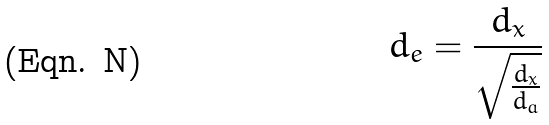Convert formula to latex. <formula><loc_0><loc_0><loc_500><loc_500>d _ { e } = \frac { d _ { x } } { \sqrt { \frac { d _ { x } } { d _ { a } } } }</formula> 